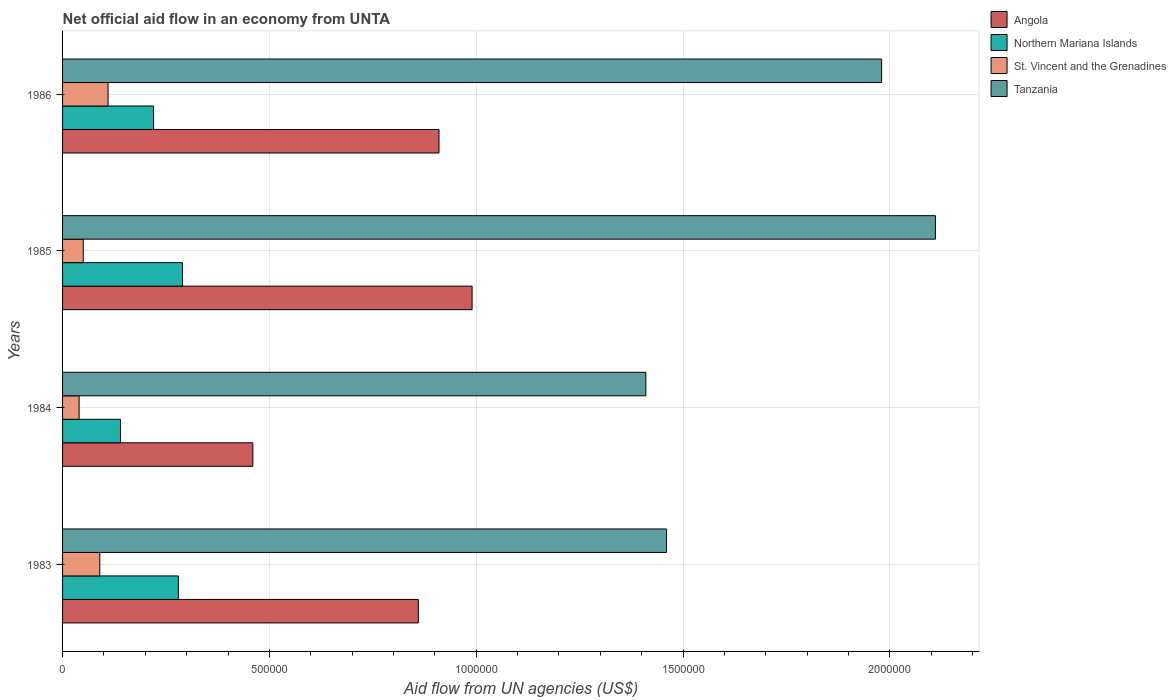How many different coloured bars are there?
Give a very brief answer. 4. How many groups of bars are there?
Give a very brief answer. 4. How many bars are there on the 4th tick from the top?
Make the answer very short. 4. How many bars are there on the 1st tick from the bottom?
Your answer should be very brief. 4. Across all years, what is the maximum net official aid flow in Angola?
Provide a succinct answer. 9.90e+05. Across all years, what is the minimum net official aid flow in Tanzania?
Your answer should be very brief. 1.41e+06. In which year was the net official aid flow in Northern Mariana Islands maximum?
Offer a terse response. 1985. In which year was the net official aid flow in Angola minimum?
Give a very brief answer. 1984. What is the total net official aid flow in Angola in the graph?
Your answer should be very brief. 3.22e+06. What is the difference between the net official aid flow in Angola in 1984 and the net official aid flow in Northern Mariana Islands in 1986?
Provide a succinct answer. 2.40e+05. What is the average net official aid flow in Northern Mariana Islands per year?
Your response must be concise. 2.32e+05. In the year 1984, what is the difference between the net official aid flow in Tanzania and net official aid flow in St. Vincent and the Grenadines?
Your answer should be very brief. 1.37e+06. In how many years, is the net official aid flow in Angola greater than 2100000 US$?
Your response must be concise. 0. What is the ratio of the net official aid flow in Tanzania in 1984 to that in 1985?
Offer a terse response. 0.67. Is the net official aid flow in Angola in 1985 less than that in 1986?
Your answer should be very brief. No. What is the difference between the highest and the lowest net official aid flow in Angola?
Offer a terse response. 5.30e+05. What does the 1st bar from the top in 1983 represents?
Provide a succinct answer. Tanzania. What does the 1st bar from the bottom in 1985 represents?
Ensure brevity in your answer.  Angola. How many bars are there?
Give a very brief answer. 16. Are all the bars in the graph horizontal?
Your answer should be very brief. Yes. How many years are there in the graph?
Your answer should be compact. 4. Are the values on the major ticks of X-axis written in scientific E-notation?
Give a very brief answer. No. Does the graph contain any zero values?
Offer a very short reply. No. Does the graph contain grids?
Your response must be concise. Yes. How many legend labels are there?
Keep it short and to the point. 4. What is the title of the graph?
Give a very brief answer. Net official aid flow in an economy from UNTA. What is the label or title of the X-axis?
Offer a terse response. Aid flow from UN agencies (US$). What is the label or title of the Y-axis?
Provide a short and direct response. Years. What is the Aid flow from UN agencies (US$) in Angola in 1983?
Keep it short and to the point. 8.60e+05. What is the Aid flow from UN agencies (US$) of Northern Mariana Islands in 1983?
Provide a succinct answer. 2.80e+05. What is the Aid flow from UN agencies (US$) in St. Vincent and the Grenadines in 1983?
Your answer should be compact. 9.00e+04. What is the Aid flow from UN agencies (US$) in Tanzania in 1983?
Make the answer very short. 1.46e+06. What is the Aid flow from UN agencies (US$) in Northern Mariana Islands in 1984?
Ensure brevity in your answer.  1.40e+05. What is the Aid flow from UN agencies (US$) of St. Vincent and the Grenadines in 1984?
Your answer should be compact. 4.00e+04. What is the Aid flow from UN agencies (US$) of Tanzania in 1984?
Offer a terse response. 1.41e+06. What is the Aid flow from UN agencies (US$) in Angola in 1985?
Offer a very short reply. 9.90e+05. What is the Aid flow from UN agencies (US$) in Northern Mariana Islands in 1985?
Provide a short and direct response. 2.90e+05. What is the Aid flow from UN agencies (US$) in Tanzania in 1985?
Give a very brief answer. 2.11e+06. What is the Aid flow from UN agencies (US$) of Angola in 1986?
Offer a very short reply. 9.10e+05. What is the Aid flow from UN agencies (US$) in Northern Mariana Islands in 1986?
Make the answer very short. 2.20e+05. What is the Aid flow from UN agencies (US$) in Tanzania in 1986?
Your response must be concise. 1.98e+06. Across all years, what is the maximum Aid flow from UN agencies (US$) of Angola?
Provide a succinct answer. 9.90e+05. Across all years, what is the maximum Aid flow from UN agencies (US$) of Northern Mariana Islands?
Your answer should be compact. 2.90e+05. Across all years, what is the maximum Aid flow from UN agencies (US$) in Tanzania?
Provide a succinct answer. 2.11e+06. Across all years, what is the minimum Aid flow from UN agencies (US$) in St. Vincent and the Grenadines?
Provide a short and direct response. 4.00e+04. Across all years, what is the minimum Aid flow from UN agencies (US$) of Tanzania?
Your response must be concise. 1.41e+06. What is the total Aid flow from UN agencies (US$) of Angola in the graph?
Ensure brevity in your answer.  3.22e+06. What is the total Aid flow from UN agencies (US$) of Northern Mariana Islands in the graph?
Keep it short and to the point. 9.30e+05. What is the total Aid flow from UN agencies (US$) in St. Vincent and the Grenadines in the graph?
Offer a terse response. 2.90e+05. What is the total Aid flow from UN agencies (US$) in Tanzania in the graph?
Ensure brevity in your answer.  6.96e+06. What is the difference between the Aid flow from UN agencies (US$) in Angola in 1983 and that in 1984?
Your response must be concise. 4.00e+05. What is the difference between the Aid flow from UN agencies (US$) in St. Vincent and the Grenadines in 1983 and that in 1984?
Your answer should be very brief. 5.00e+04. What is the difference between the Aid flow from UN agencies (US$) in Northern Mariana Islands in 1983 and that in 1985?
Ensure brevity in your answer.  -10000. What is the difference between the Aid flow from UN agencies (US$) of Tanzania in 1983 and that in 1985?
Provide a short and direct response. -6.50e+05. What is the difference between the Aid flow from UN agencies (US$) in Angola in 1983 and that in 1986?
Offer a very short reply. -5.00e+04. What is the difference between the Aid flow from UN agencies (US$) of Tanzania in 1983 and that in 1986?
Your answer should be very brief. -5.20e+05. What is the difference between the Aid flow from UN agencies (US$) in Angola in 1984 and that in 1985?
Give a very brief answer. -5.30e+05. What is the difference between the Aid flow from UN agencies (US$) of Northern Mariana Islands in 1984 and that in 1985?
Offer a very short reply. -1.50e+05. What is the difference between the Aid flow from UN agencies (US$) of St. Vincent and the Grenadines in 1984 and that in 1985?
Your response must be concise. -10000. What is the difference between the Aid flow from UN agencies (US$) in Tanzania in 1984 and that in 1985?
Give a very brief answer. -7.00e+05. What is the difference between the Aid flow from UN agencies (US$) in Angola in 1984 and that in 1986?
Provide a short and direct response. -4.50e+05. What is the difference between the Aid flow from UN agencies (US$) of Northern Mariana Islands in 1984 and that in 1986?
Your answer should be compact. -8.00e+04. What is the difference between the Aid flow from UN agencies (US$) of Tanzania in 1984 and that in 1986?
Ensure brevity in your answer.  -5.70e+05. What is the difference between the Aid flow from UN agencies (US$) in Northern Mariana Islands in 1985 and that in 1986?
Your answer should be compact. 7.00e+04. What is the difference between the Aid flow from UN agencies (US$) of Tanzania in 1985 and that in 1986?
Your answer should be very brief. 1.30e+05. What is the difference between the Aid flow from UN agencies (US$) of Angola in 1983 and the Aid flow from UN agencies (US$) of Northern Mariana Islands in 1984?
Your answer should be compact. 7.20e+05. What is the difference between the Aid flow from UN agencies (US$) in Angola in 1983 and the Aid flow from UN agencies (US$) in St. Vincent and the Grenadines in 1984?
Offer a terse response. 8.20e+05. What is the difference between the Aid flow from UN agencies (US$) of Angola in 1983 and the Aid flow from UN agencies (US$) of Tanzania in 1984?
Provide a succinct answer. -5.50e+05. What is the difference between the Aid flow from UN agencies (US$) of Northern Mariana Islands in 1983 and the Aid flow from UN agencies (US$) of Tanzania in 1984?
Offer a terse response. -1.13e+06. What is the difference between the Aid flow from UN agencies (US$) in St. Vincent and the Grenadines in 1983 and the Aid flow from UN agencies (US$) in Tanzania in 1984?
Make the answer very short. -1.32e+06. What is the difference between the Aid flow from UN agencies (US$) of Angola in 1983 and the Aid flow from UN agencies (US$) of Northern Mariana Islands in 1985?
Ensure brevity in your answer.  5.70e+05. What is the difference between the Aid flow from UN agencies (US$) in Angola in 1983 and the Aid flow from UN agencies (US$) in St. Vincent and the Grenadines in 1985?
Your answer should be compact. 8.10e+05. What is the difference between the Aid flow from UN agencies (US$) of Angola in 1983 and the Aid flow from UN agencies (US$) of Tanzania in 1985?
Your response must be concise. -1.25e+06. What is the difference between the Aid flow from UN agencies (US$) of Northern Mariana Islands in 1983 and the Aid flow from UN agencies (US$) of St. Vincent and the Grenadines in 1985?
Ensure brevity in your answer.  2.30e+05. What is the difference between the Aid flow from UN agencies (US$) of Northern Mariana Islands in 1983 and the Aid flow from UN agencies (US$) of Tanzania in 1985?
Provide a succinct answer. -1.83e+06. What is the difference between the Aid flow from UN agencies (US$) in St. Vincent and the Grenadines in 1983 and the Aid flow from UN agencies (US$) in Tanzania in 1985?
Keep it short and to the point. -2.02e+06. What is the difference between the Aid flow from UN agencies (US$) of Angola in 1983 and the Aid flow from UN agencies (US$) of Northern Mariana Islands in 1986?
Offer a terse response. 6.40e+05. What is the difference between the Aid flow from UN agencies (US$) of Angola in 1983 and the Aid flow from UN agencies (US$) of St. Vincent and the Grenadines in 1986?
Your answer should be very brief. 7.50e+05. What is the difference between the Aid flow from UN agencies (US$) of Angola in 1983 and the Aid flow from UN agencies (US$) of Tanzania in 1986?
Make the answer very short. -1.12e+06. What is the difference between the Aid flow from UN agencies (US$) of Northern Mariana Islands in 1983 and the Aid flow from UN agencies (US$) of St. Vincent and the Grenadines in 1986?
Your answer should be very brief. 1.70e+05. What is the difference between the Aid flow from UN agencies (US$) in Northern Mariana Islands in 1983 and the Aid flow from UN agencies (US$) in Tanzania in 1986?
Your answer should be compact. -1.70e+06. What is the difference between the Aid flow from UN agencies (US$) in St. Vincent and the Grenadines in 1983 and the Aid flow from UN agencies (US$) in Tanzania in 1986?
Provide a short and direct response. -1.89e+06. What is the difference between the Aid flow from UN agencies (US$) of Angola in 1984 and the Aid flow from UN agencies (US$) of St. Vincent and the Grenadines in 1985?
Make the answer very short. 4.10e+05. What is the difference between the Aid flow from UN agencies (US$) of Angola in 1984 and the Aid flow from UN agencies (US$) of Tanzania in 1985?
Provide a short and direct response. -1.65e+06. What is the difference between the Aid flow from UN agencies (US$) in Northern Mariana Islands in 1984 and the Aid flow from UN agencies (US$) in St. Vincent and the Grenadines in 1985?
Your answer should be compact. 9.00e+04. What is the difference between the Aid flow from UN agencies (US$) of Northern Mariana Islands in 1984 and the Aid flow from UN agencies (US$) of Tanzania in 1985?
Your response must be concise. -1.97e+06. What is the difference between the Aid flow from UN agencies (US$) of St. Vincent and the Grenadines in 1984 and the Aid flow from UN agencies (US$) of Tanzania in 1985?
Offer a very short reply. -2.07e+06. What is the difference between the Aid flow from UN agencies (US$) in Angola in 1984 and the Aid flow from UN agencies (US$) in Tanzania in 1986?
Offer a terse response. -1.52e+06. What is the difference between the Aid flow from UN agencies (US$) in Northern Mariana Islands in 1984 and the Aid flow from UN agencies (US$) in Tanzania in 1986?
Your response must be concise. -1.84e+06. What is the difference between the Aid flow from UN agencies (US$) of St. Vincent and the Grenadines in 1984 and the Aid flow from UN agencies (US$) of Tanzania in 1986?
Ensure brevity in your answer.  -1.94e+06. What is the difference between the Aid flow from UN agencies (US$) of Angola in 1985 and the Aid flow from UN agencies (US$) of Northern Mariana Islands in 1986?
Make the answer very short. 7.70e+05. What is the difference between the Aid flow from UN agencies (US$) in Angola in 1985 and the Aid flow from UN agencies (US$) in St. Vincent and the Grenadines in 1986?
Make the answer very short. 8.80e+05. What is the difference between the Aid flow from UN agencies (US$) of Angola in 1985 and the Aid flow from UN agencies (US$) of Tanzania in 1986?
Give a very brief answer. -9.90e+05. What is the difference between the Aid flow from UN agencies (US$) in Northern Mariana Islands in 1985 and the Aid flow from UN agencies (US$) in St. Vincent and the Grenadines in 1986?
Keep it short and to the point. 1.80e+05. What is the difference between the Aid flow from UN agencies (US$) in Northern Mariana Islands in 1985 and the Aid flow from UN agencies (US$) in Tanzania in 1986?
Provide a short and direct response. -1.69e+06. What is the difference between the Aid flow from UN agencies (US$) of St. Vincent and the Grenadines in 1985 and the Aid flow from UN agencies (US$) of Tanzania in 1986?
Make the answer very short. -1.93e+06. What is the average Aid flow from UN agencies (US$) of Angola per year?
Ensure brevity in your answer.  8.05e+05. What is the average Aid flow from UN agencies (US$) in Northern Mariana Islands per year?
Provide a succinct answer. 2.32e+05. What is the average Aid flow from UN agencies (US$) of St. Vincent and the Grenadines per year?
Keep it short and to the point. 7.25e+04. What is the average Aid flow from UN agencies (US$) in Tanzania per year?
Provide a succinct answer. 1.74e+06. In the year 1983, what is the difference between the Aid flow from UN agencies (US$) in Angola and Aid flow from UN agencies (US$) in Northern Mariana Islands?
Give a very brief answer. 5.80e+05. In the year 1983, what is the difference between the Aid flow from UN agencies (US$) of Angola and Aid flow from UN agencies (US$) of St. Vincent and the Grenadines?
Provide a succinct answer. 7.70e+05. In the year 1983, what is the difference between the Aid flow from UN agencies (US$) in Angola and Aid flow from UN agencies (US$) in Tanzania?
Your answer should be compact. -6.00e+05. In the year 1983, what is the difference between the Aid flow from UN agencies (US$) in Northern Mariana Islands and Aid flow from UN agencies (US$) in St. Vincent and the Grenadines?
Make the answer very short. 1.90e+05. In the year 1983, what is the difference between the Aid flow from UN agencies (US$) of Northern Mariana Islands and Aid flow from UN agencies (US$) of Tanzania?
Your answer should be very brief. -1.18e+06. In the year 1983, what is the difference between the Aid flow from UN agencies (US$) in St. Vincent and the Grenadines and Aid flow from UN agencies (US$) in Tanzania?
Offer a very short reply. -1.37e+06. In the year 1984, what is the difference between the Aid flow from UN agencies (US$) in Angola and Aid flow from UN agencies (US$) in Tanzania?
Offer a terse response. -9.50e+05. In the year 1984, what is the difference between the Aid flow from UN agencies (US$) in Northern Mariana Islands and Aid flow from UN agencies (US$) in Tanzania?
Make the answer very short. -1.27e+06. In the year 1984, what is the difference between the Aid flow from UN agencies (US$) in St. Vincent and the Grenadines and Aid flow from UN agencies (US$) in Tanzania?
Make the answer very short. -1.37e+06. In the year 1985, what is the difference between the Aid flow from UN agencies (US$) in Angola and Aid flow from UN agencies (US$) in Northern Mariana Islands?
Your answer should be compact. 7.00e+05. In the year 1985, what is the difference between the Aid flow from UN agencies (US$) of Angola and Aid flow from UN agencies (US$) of St. Vincent and the Grenadines?
Provide a succinct answer. 9.40e+05. In the year 1985, what is the difference between the Aid flow from UN agencies (US$) of Angola and Aid flow from UN agencies (US$) of Tanzania?
Offer a very short reply. -1.12e+06. In the year 1985, what is the difference between the Aid flow from UN agencies (US$) of Northern Mariana Islands and Aid flow from UN agencies (US$) of St. Vincent and the Grenadines?
Your answer should be very brief. 2.40e+05. In the year 1985, what is the difference between the Aid flow from UN agencies (US$) of Northern Mariana Islands and Aid flow from UN agencies (US$) of Tanzania?
Your answer should be very brief. -1.82e+06. In the year 1985, what is the difference between the Aid flow from UN agencies (US$) of St. Vincent and the Grenadines and Aid flow from UN agencies (US$) of Tanzania?
Provide a short and direct response. -2.06e+06. In the year 1986, what is the difference between the Aid flow from UN agencies (US$) of Angola and Aid flow from UN agencies (US$) of Northern Mariana Islands?
Ensure brevity in your answer.  6.90e+05. In the year 1986, what is the difference between the Aid flow from UN agencies (US$) in Angola and Aid flow from UN agencies (US$) in Tanzania?
Give a very brief answer. -1.07e+06. In the year 1986, what is the difference between the Aid flow from UN agencies (US$) in Northern Mariana Islands and Aid flow from UN agencies (US$) in Tanzania?
Your response must be concise. -1.76e+06. In the year 1986, what is the difference between the Aid flow from UN agencies (US$) in St. Vincent and the Grenadines and Aid flow from UN agencies (US$) in Tanzania?
Offer a terse response. -1.87e+06. What is the ratio of the Aid flow from UN agencies (US$) of Angola in 1983 to that in 1984?
Your response must be concise. 1.87. What is the ratio of the Aid flow from UN agencies (US$) in St. Vincent and the Grenadines in 1983 to that in 1984?
Your answer should be very brief. 2.25. What is the ratio of the Aid flow from UN agencies (US$) in Tanzania in 1983 to that in 1984?
Ensure brevity in your answer.  1.04. What is the ratio of the Aid flow from UN agencies (US$) of Angola in 1983 to that in 1985?
Ensure brevity in your answer.  0.87. What is the ratio of the Aid flow from UN agencies (US$) in Northern Mariana Islands in 1983 to that in 1985?
Your answer should be compact. 0.97. What is the ratio of the Aid flow from UN agencies (US$) in St. Vincent and the Grenadines in 1983 to that in 1985?
Make the answer very short. 1.8. What is the ratio of the Aid flow from UN agencies (US$) in Tanzania in 1983 to that in 1985?
Provide a succinct answer. 0.69. What is the ratio of the Aid flow from UN agencies (US$) of Angola in 1983 to that in 1986?
Your answer should be compact. 0.95. What is the ratio of the Aid flow from UN agencies (US$) of Northern Mariana Islands in 1983 to that in 1986?
Your answer should be very brief. 1.27. What is the ratio of the Aid flow from UN agencies (US$) in St. Vincent and the Grenadines in 1983 to that in 1986?
Your response must be concise. 0.82. What is the ratio of the Aid flow from UN agencies (US$) in Tanzania in 1983 to that in 1986?
Provide a short and direct response. 0.74. What is the ratio of the Aid flow from UN agencies (US$) in Angola in 1984 to that in 1985?
Your response must be concise. 0.46. What is the ratio of the Aid flow from UN agencies (US$) of Northern Mariana Islands in 1984 to that in 1985?
Your response must be concise. 0.48. What is the ratio of the Aid flow from UN agencies (US$) in Tanzania in 1984 to that in 1985?
Ensure brevity in your answer.  0.67. What is the ratio of the Aid flow from UN agencies (US$) of Angola in 1984 to that in 1986?
Provide a short and direct response. 0.51. What is the ratio of the Aid flow from UN agencies (US$) of Northern Mariana Islands in 1984 to that in 1986?
Give a very brief answer. 0.64. What is the ratio of the Aid flow from UN agencies (US$) of St. Vincent and the Grenadines in 1984 to that in 1986?
Make the answer very short. 0.36. What is the ratio of the Aid flow from UN agencies (US$) of Tanzania in 1984 to that in 1986?
Provide a short and direct response. 0.71. What is the ratio of the Aid flow from UN agencies (US$) of Angola in 1985 to that in 1986?
Offer a terse response. 1.09. What is the ratio of the Aid flow from UN agencies (US$) of Northern Mariana Islands in 1985 to that in 1986?
Provide a short and direct response. 1.32. What is the ratio of the Aid flow from UN agencies (US$) in St. Vincent and the Grenadines in 1985 to that in 1986?
Your response must be concise. 0.45. What is the ratio of the Aid flow from UN agencies (US$) in Tanzania in 1985 to that in 1986?
Keep it short and to the point. 1.07. What is the difference between the highest and the second highest Aid flow from UN agencies (US$) in Angola?
Offer a very short reply. 8.00e+04. What is the difference between the highest and the second highest Aid flow from UN agencies (US$) in Northern Mariana Islands?
Your answer should be compact. 10000. What is the difference between the highest and the lowest Aid flow from UN agencies (US$) in Angola?
Provide a short and direct response. 5.30e+05. What is the difference between the highest and the lowest Aid flow from UN agencies (US$) in St. Vincent and the Grenadines?
Provide a succinct answer. 7.00e+04. 